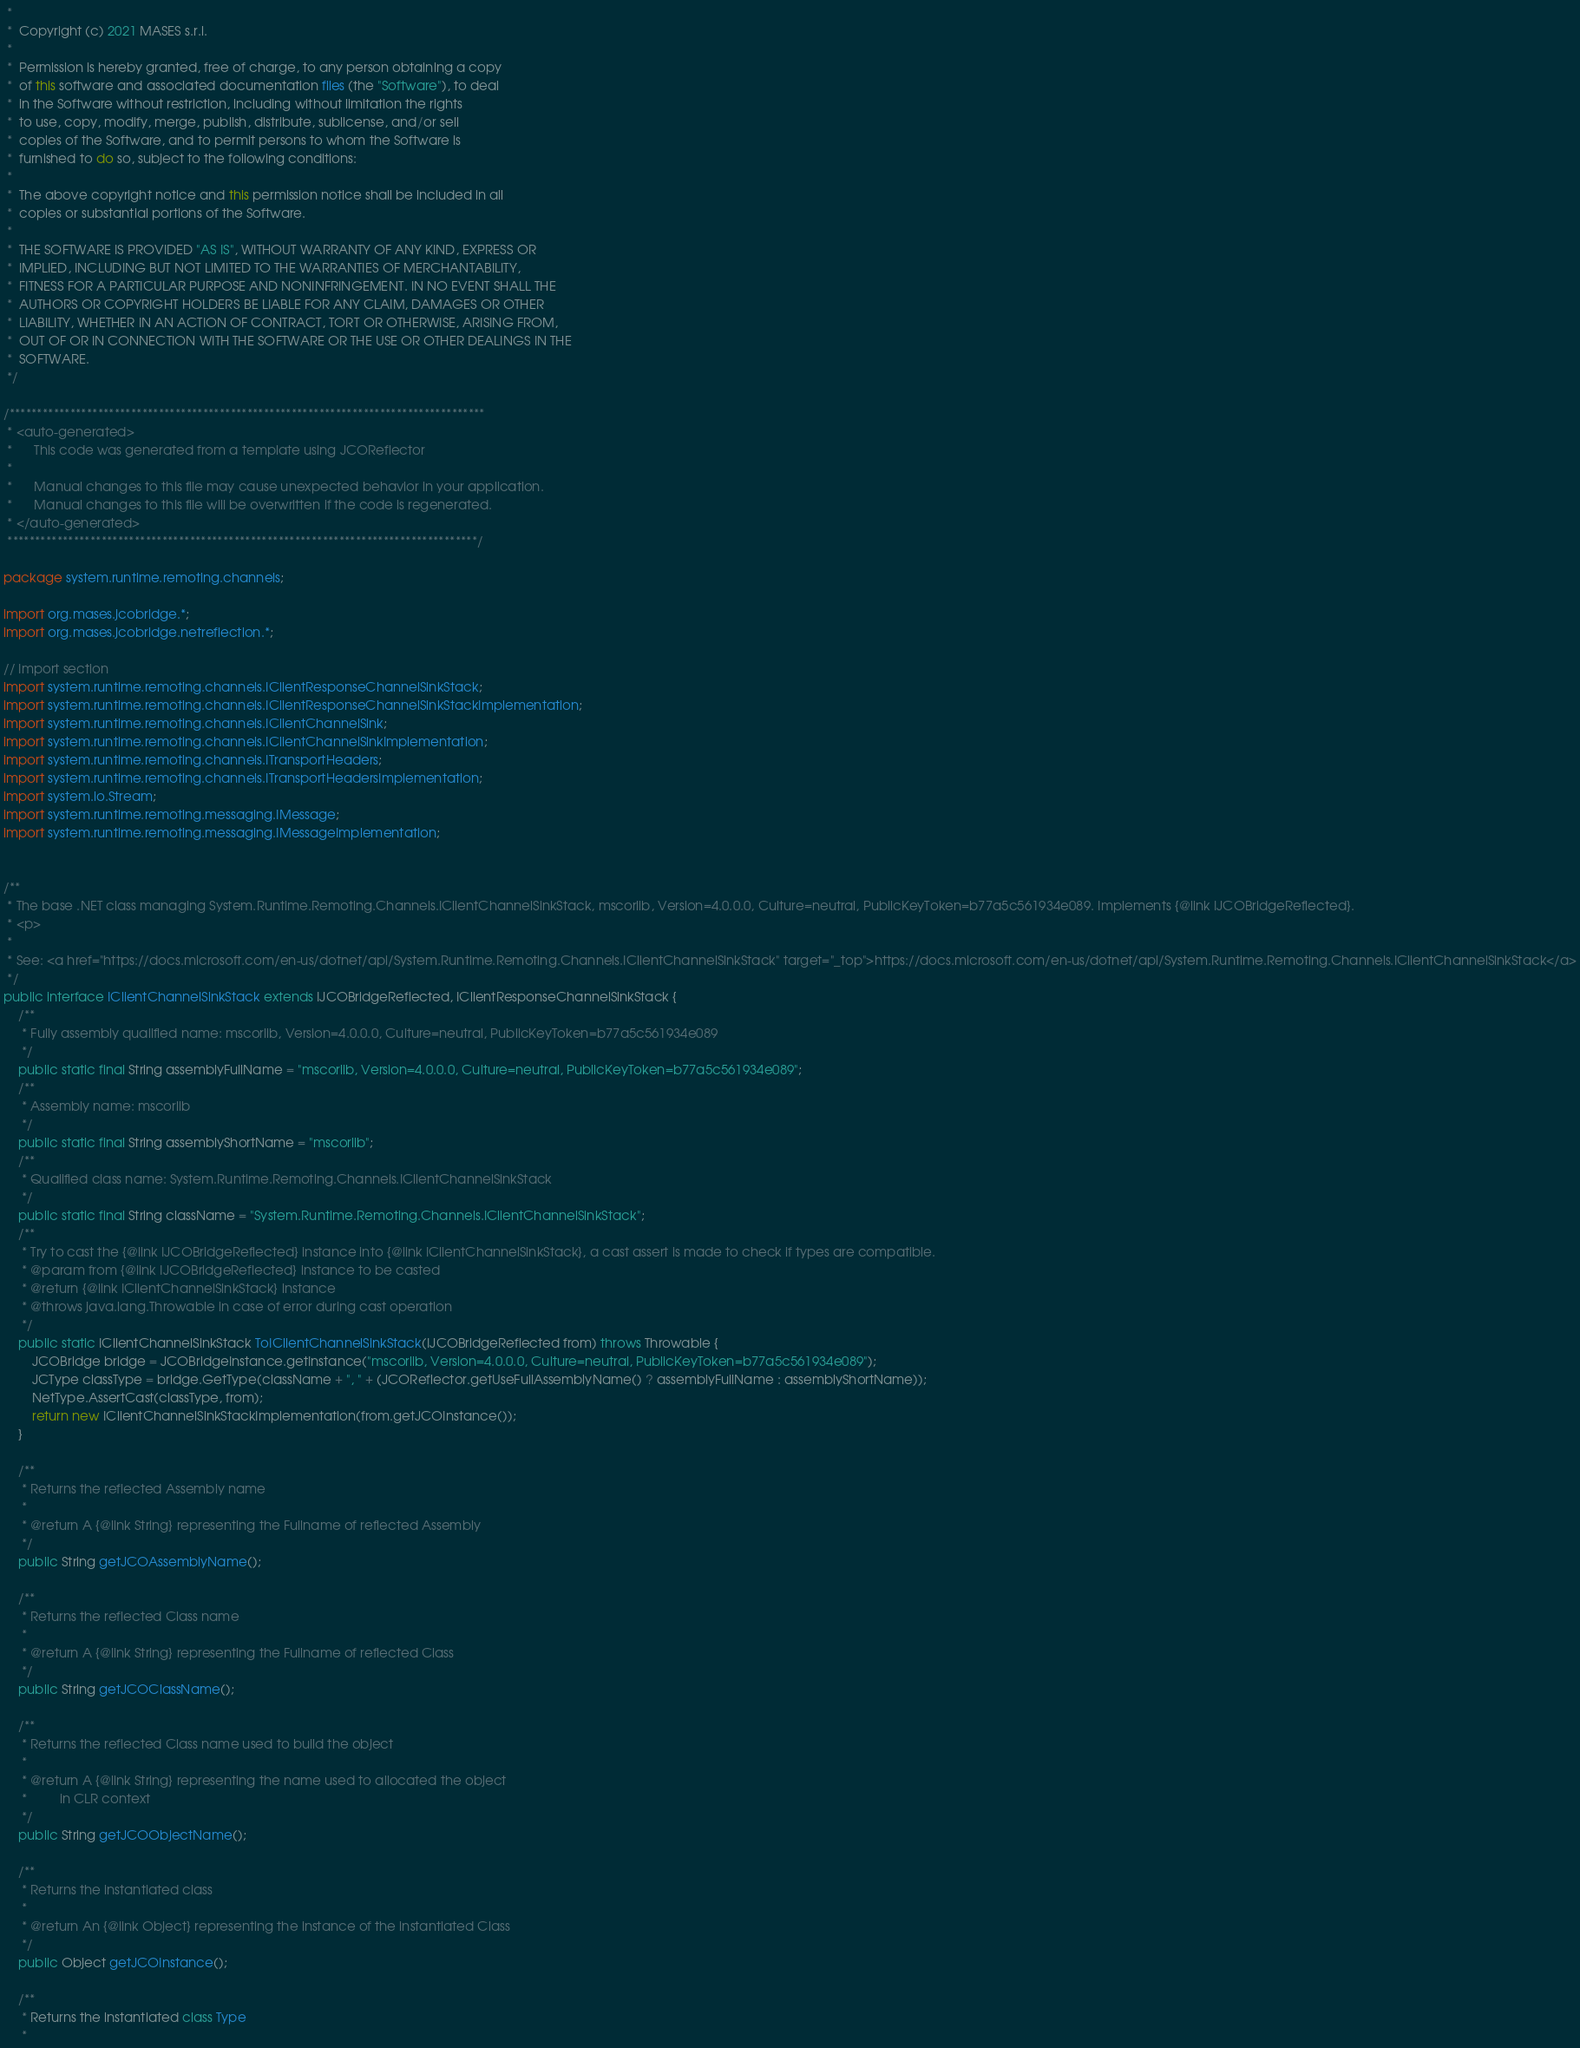Convert code to text. <code><loc_0><loc_0><loc_500><loc_500><_Java_> *
 *  Copyright (c) 2021 MASES s.r.l.
 *
 *  Permission is hereby granted, free of charge, to any person obtaining a copy
 *  of this software and associated documentation files (the "Software"), to deal
 *  in the Software without restriction, including without limitation the rights
 *  to use, copy, modify, merge, publish, distribute, sublicense, and/or sell
 *  copies of the Software, and to permit persons to whom the Software is
 *  furnished to do so, subject to the following conditions:
 *
 *  The above copyright notice and this permission notice shall be included in all
 *  copies or substantial portions of the Software.
 *
 *  THE SOFTWARE IS PROVIDED "AS IS", WITHOUT WARRANTY OF ANY KIND, EXPRESS OR
 *  IMPLIED, INCLUDING BUT NOT LIMITED TO THE WARRANTIES OF MERCHANTABILITY,
 *  FITNESS FOR A PARTICULAR PURPOSE AND NONINFRINGEMENT. IN NO EVENT SHALL THE
 *  AUTHORS OR COPYRIGHT HOLDERS BE LIABLE FOR ANY CLAIM, DAMAGES OR OTHER
 *  LIABILITY, WHETHER IN AN ACTION OF CONTRACT, TORT OR OTHERWISE, ARISING FROM,
 *  OUT OF OR IN CONNECTION WITH THE SOFTWARE OR THE USE OR OTHER DEALINGS IN THE
 *  SOFTWARE.
 */

/**************************************************************************************
 * <auto-generated>
 *      This code was generated from a template using JCOReflector
 * 
 *      Manual changes to this file may cause unexpected behavior in your application.
 *      Manual changes to this file will be overwritten if the code is regenerated.
 * </auto-generated>
 *************************************************************************************/

package system.runtime.remoting.channels;

import org.mases.jcobridge.*;
import org.mases.jcobridge.netreflection.*;

// Import section
import system.runtime.remoting.channels.IClientResponseChannelSinkStack;
import system.runtime.remoting.channels.IClientResponseChannelSinkStackImplementation;
import system.runtime.remoting.channels.IClientChannelSink;
import system.runtime.remoting.channels.IClientChannelSinkImplementation;
import system.runtime.remoting.channels.ITransportHeaders;
import system.runtime.remoting.channels.ITransportHeadersImplementation;
import system.io.Stream;
import system.runtime.remoting.messaging.IMessage;
import system.runtime.remoting.messaging.IMessageImplementation;


/**
 * The base .NET class managing System.Runtime.Remoting.Channels.IClientChannelSinkStack, mscorlib, Version=4.0.0.0, Culture=neutral, PublicKeyToken=b77a5c561934e089. Implements {@link IJCOBridgeReflected}.
 * <p>
 * 
 * See: <a href="https://docs.microsoft.com/en-us/dotnet/api/System.Runtime.Remoting.Channels.IClientChannelSinkStack" target="_top">https://docs.microsoft.com/en-us/dotnet/api/System.Runtime.Remoting.Channels.IClientChannelSinkStack</a>
 */
public interface IClientChannelSinkStack extends IJCOBridgeReflected, IClientResponseChannelSinkStack {
    /**
     * Fully assembly qualified name: mscorlib, Version=4.0.0.0, Culture=neutral, PublicKeyToken=b77a5c561934e089
     */
    public static final String assemblyFullName = "mscorlib, Version=4.0.0.0, Culture=neutral, PublicKeyToken=b77a5c561934e089";
    /**
     * Assembly name: mscorlib
     */
    public static final String assemblyShortName = "mscorlib";
    /**
     * Qualified class name: System.Runtime.Remoting.Channels.IClientChannelSinkStack
     */
    public static final String className = "System.Runtime.Remoting.Channels.IClientChannelSinkStack";
    /**
     * Try to cast the {@link IJCOBridgeReflected} instance into {@link IClientChannelSinkStack}, a cast assert is made to check if types are compatible.
     * @param from {@link IJCOBridgeReflected} instance to be casted
     * @return {@link IClientChannelSinkStack} instance
     * @throws java.lang.Throwable in case of error during cast operation
     */
    public static IClientChannelSinkStack ToIClientChannelSinkStack(IJCOBridgeReflected from) throws Throwable {
        JCOBridge bridge = JCOBridgeInstance.getInstance("mscorlib, Version=4.0.0.0, Culture=neutral, PublicKeyToken=b77a5c561934e089");
        JCType classType = bridge.GetType(className + ", " + (JCOReflector.getUseFullAssemblyName() ? assemblyFullName : assemblyShortName));
        NetType.AssertCast(classType, from);
        return new IClientChannelSinkStackImplementation(from.getJCOInstance());
    }

    /**
     * Returns the reflected Assembly name
     * 
     * @return A {@link String} representing the Fullname of reflected Assembly
     */
    public String getJCOAssemblyName();

    /**
     * Returns the reflected Class name
     * 
     * @return A {@link String} representing the Fullname of reflected Class
     */
    public String getJCOClassName();

    /**
     * Returns the reflected Class name used to build the object
     * 
     * @return A {@link String} representing the name used to allocated the object
     *         in CLR context
     */
    public String getJCOObjectName();

    /**
     * Returns the instantiated class
     * 
     * @return An {@link Object} representing the instance of the instantiated Class
     */
    public Object getJCOInstance();

    /**
     * Returns the instantiated class Type
     * </code> 